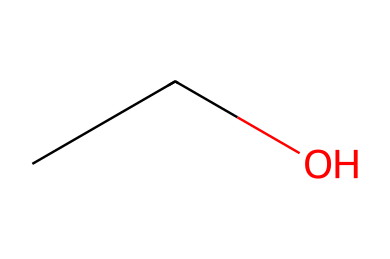What is the name of this chemical? The provided SMILES representation "CCO" corresponds to ethanol, which is a common alcohol. The two carbon atoms and the hydroxyl group indicate that it is an alcohol.
Answer: ethanol How many carbon atoms are present in the structure? The SMILES "CCO" indicates that there are two 'C' atoms in the structure, which represent the carbon atoms.
Answer: 2 What functional group is present in ethanol? In the structure "CCO", the '-OH' part indicates the presence of a hydroxyl group, which is characteristic of alcohols.
Answer: hydroxyl What is the total number of hydrogen atoms in ethanol? Each carbon in ethanol forms a total of four bonds. The two carbon atoms bond with a hydroxyl group and have three hydrogen atoms combined. Thus, the total is five hydrogen atoms in the molecule.
Answer: 6 Is ethanol a carbene? Carbenes are typically neutral species containing a divalent carbon atom with only six electrons. Ethanol, with its structure containing functional groups and saturated carbon atoms, does not fit the definition of a carbene.
Answer: no What type of bonding is present in the C-C bond of ethanol? The C-C bond in ethanol is a single bond, as indicated by the representation in the SMILES "CCO", which shows two carbon atoms connected with no indication of double or triple bonding.
Answer: single bond 